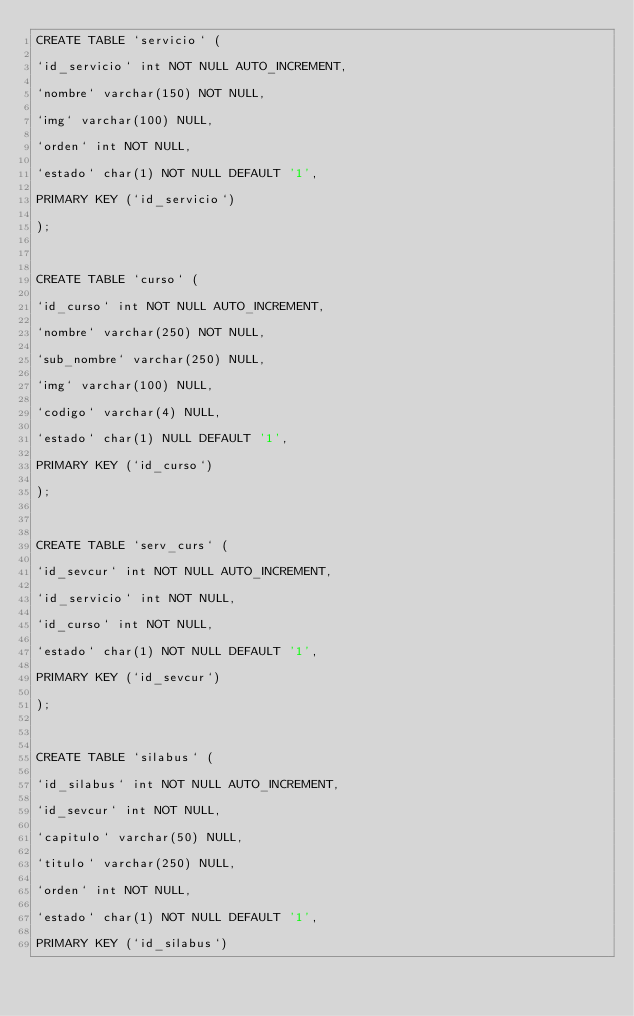<code> <loc_0><loc_0><loc_500><loc_500><_SQL_>CREATE TABLE `servicio` (
`id_servicio` int NOT NULL AUTO_INCREMENT,
`nombre` varchar(150) NOT NULL,
`img` varchar(100) NULL,
`orden` int NOT NULL,
`estado` char(1) NOT NULL DEFAULT '1',
PRIMARY KEY (`id_servicio`) 
);

CREATE TABLE `curso` (
`id_curso` int NOT NULL AUTO_INCREMENT,
`nombre` varchar(250) NOT NULL,
`sub_nombre` varchar(250) NULL,
`img` varchar(100) NULL,
`codigo` varchar(4) NULL,
`estado` char(1) NULL DEFAULT '1',
PRIMARY KEY (`id_curso`) 
);

CREATE TABLE `serv_curs` (
`id_sevcur` int NOT NULL AUTO_INCREMENT,
`id_servicio` int NOT NULL,
`id_curso` int NOT NULL,
`estado` char(1) NOT NULL DEFAULT '1',
PRIMARY KEY (`id_sevcur`) 
);

CREATE TABLE `silabus` (
`id_silabus` int NOT NULL AUTO_INCREMENT,
`id_sevcur` int NOT NULL,
`capitulo` varchar(50) NULL,
`titulo` varchar(250) NULL,
`orden` int NOT NULL,
`estado` char(1) NOT NULL DEFAULT '1',
PRIMARY KEY (`id_silabus`) </code> 